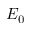<formula> <loc_0><loc_0><loc_500><loc_500>E _ { 0 }</formula> 